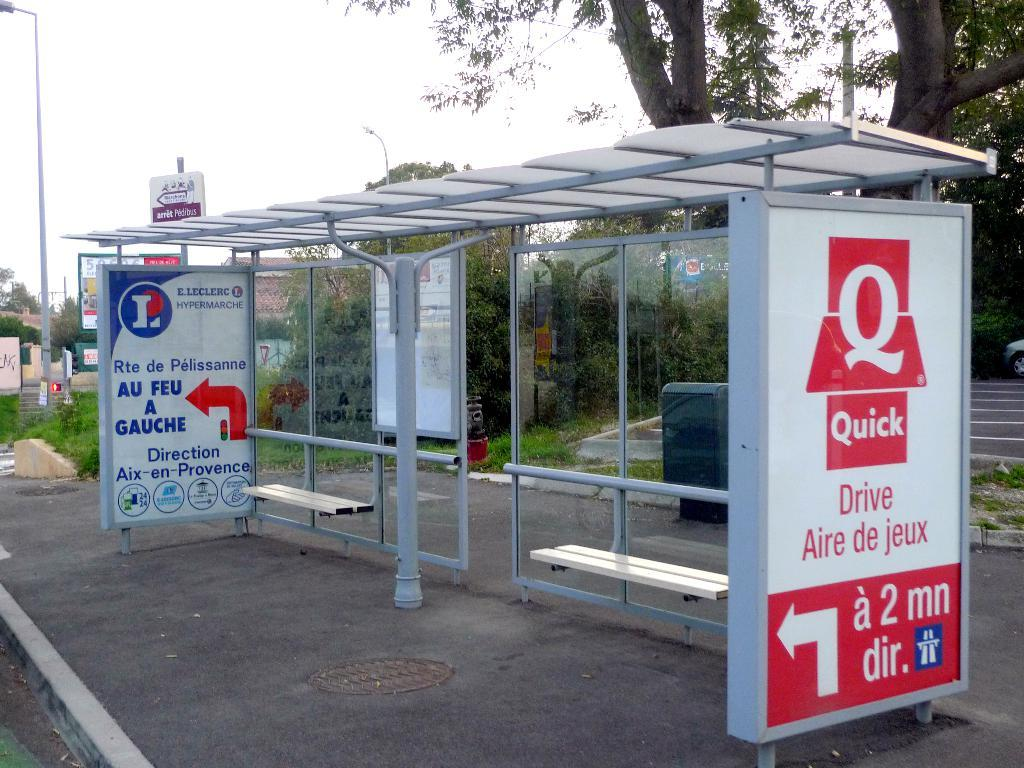What type of surface can be seen in the image? There is a sidewalk in the image. What objects are present along the sidewalk? There are metal poles and banners on the sidewalk. What type of seating is available in the image? There are benches in the image. What can be seen in the background of the image? There are trees, poles, a building, and the sky visible in the background of the image. What type of cheese is being used as a punishment in the image? There is no cheese or punishment present in the image. 